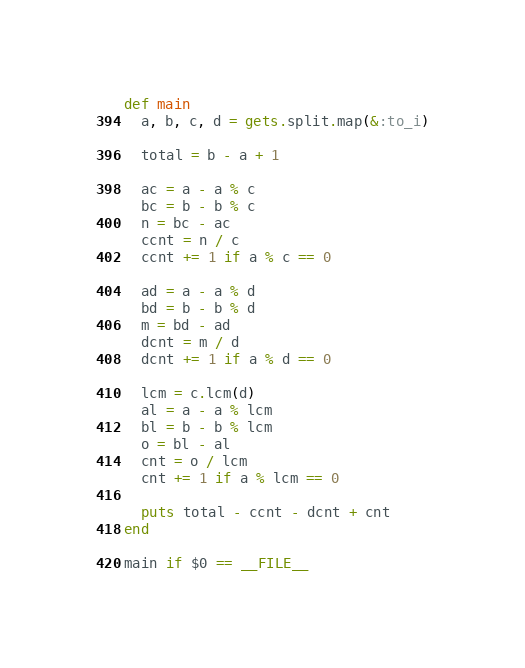<code> <loc_0><loc_0><loc_500><loc_500><_Ruby_>def main
  a, b, c, d = gets.split.map(&:to_i)

  total = b - a + 1

  ac = a - a % c
  bc = b - b % c
  n = bc - ac
  ccnt = n / c
  ccnt += 1 if a % c == 0

  ad = a - a % d
  bd = b - b % d
  m = bd - ad
  dcnt = m / d
  dcnt += 1 if a % d == 0

  lcm = c.lcm(d)
  al = a - a % lcm
  bl = b - b % lcm
  o = bl - al
  cnt = o / lcm
  cnt += 1 if a % lcm == 0

  puts total - ccnt - dcnt + cnt
end

main if $0 == __FILE__
</code> 